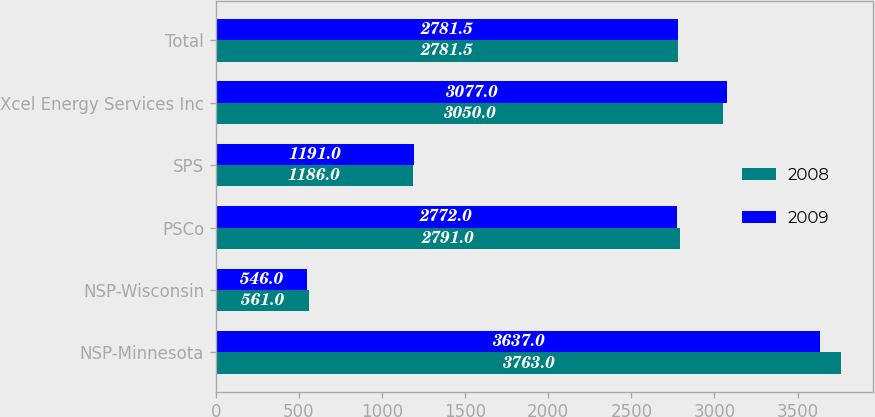Convert chart. <chart><loc_0><loc_0><loc_500><loc_500><stacked_bar_chart><ecel><fcel>NSP-Minnesota<fcel>NSP-Wisconsin<fcel>PSCo<fcel>SPS<fcel>Xcel Energy Services Inc<fcel>Total<nl><fcel>2008<fcel>3763<fcel>561<fcel>2791<fcel>1186<fcel>3050<fcel>2781.5<nl><fcel>2009<fcel>3637<fcel>546<fcel>2772<fcel>1191<fcel>3077<fcel>2781.5<nl></chart> 